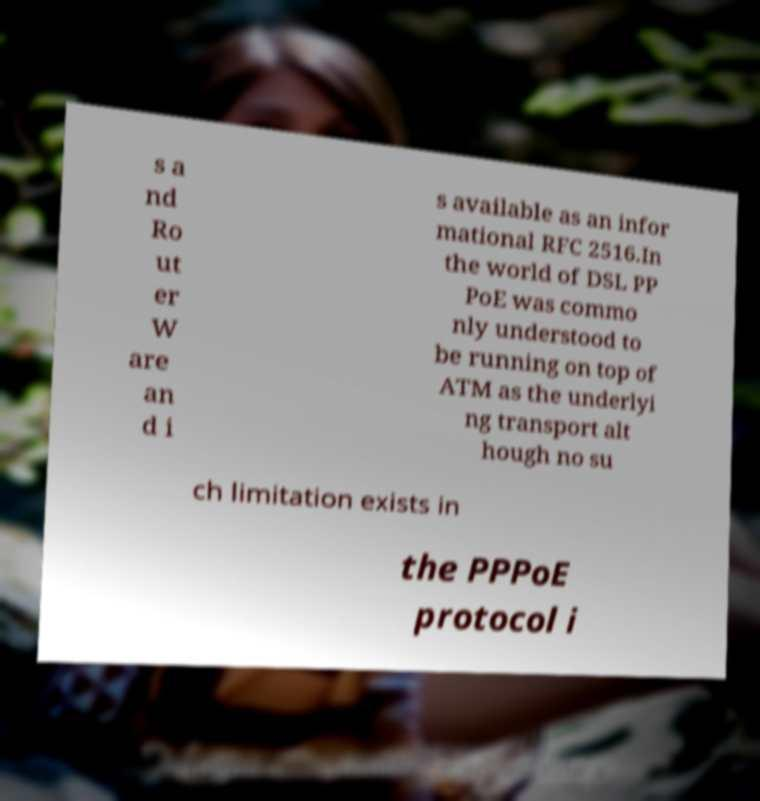Could you assist in decoding the text presented in this image and type it out clearly? s a nd Ro ut er W are an d i s available as an infor mational RFC 2516.In the world of DSL PP PoE was commo nly understood to be running on top of ATM as the underlyi ng transport alt hough no su ch limitation exists in the PPPoE protocol i 